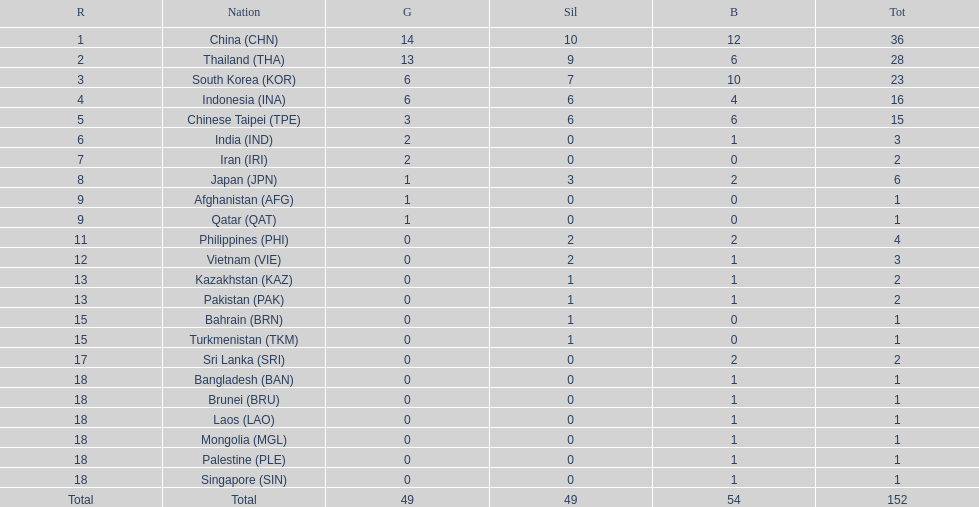In how many countries did no one win any silver medals? 11. 